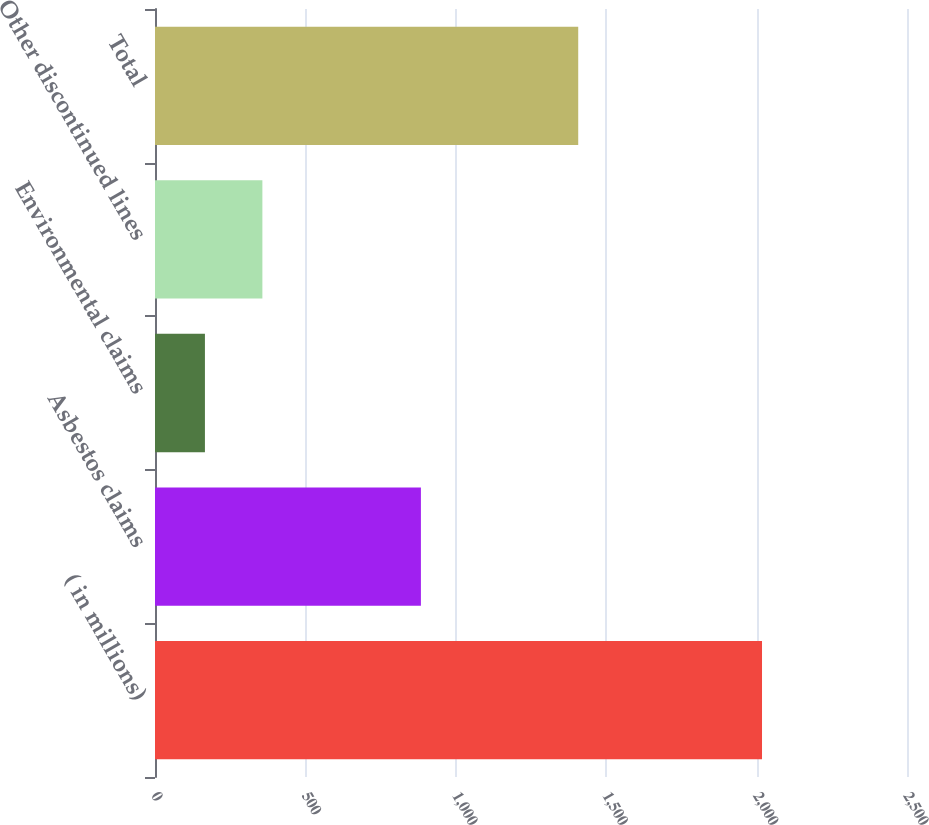<chart> <loc_0><loc_0><loc_500><loc_500><bar_chart><fcel>( in millions)<fcel>Asbestos claims<fcel>Environmental claims<fcel>Other discontinued lines<fcel>Total<nl><fcel>2018<fcel>884<fcel>166<fcel>357<fcel>1407<nl></chart> 